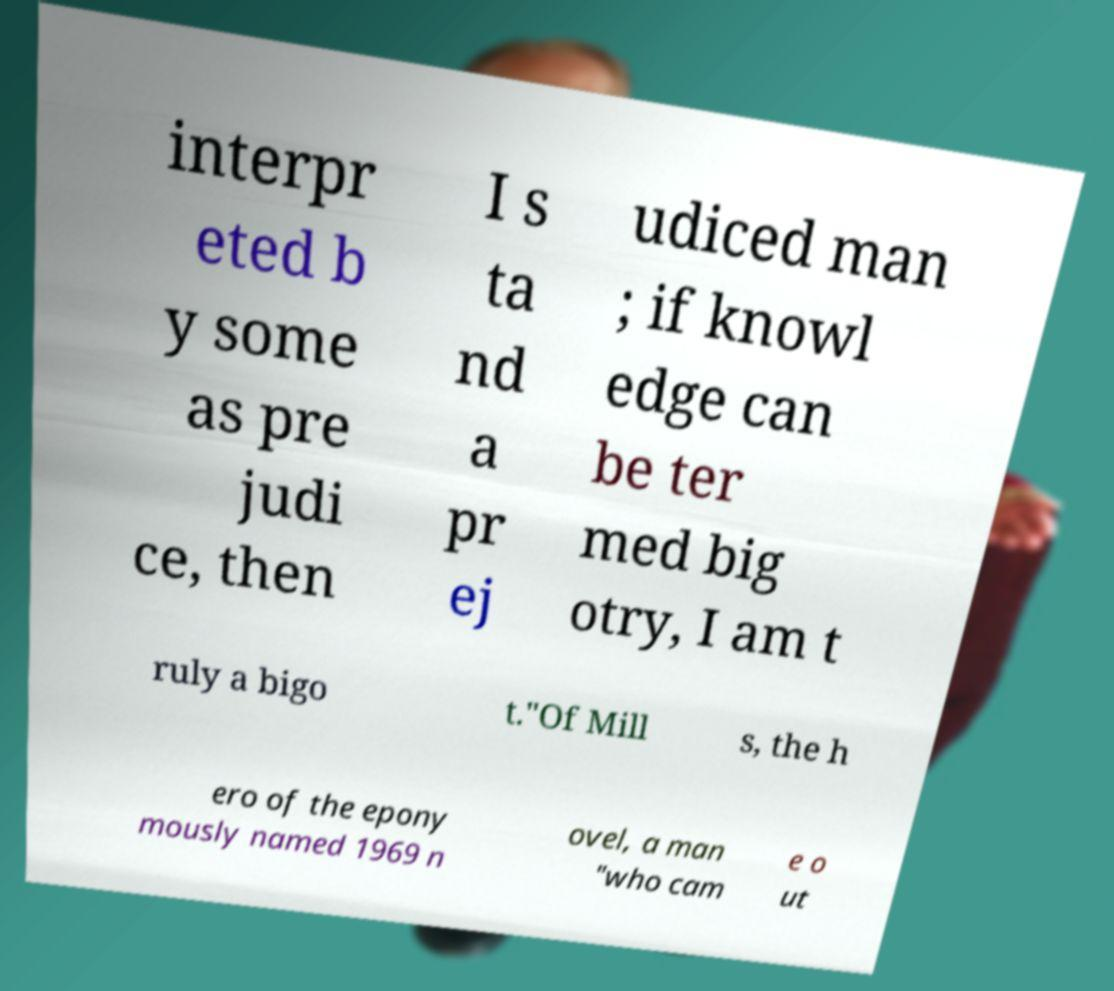Please read and relay the text visible in this image. What does it say? interpr eted b y some as pre judi ce, then I s ta nd a pr ej udiced man ; if knowl edge can be ter med big otry, I am t ruly a bigo t."Of Mill s, the h ero of the epony mously named 1969 n ovel, a man "who cam e o ut 